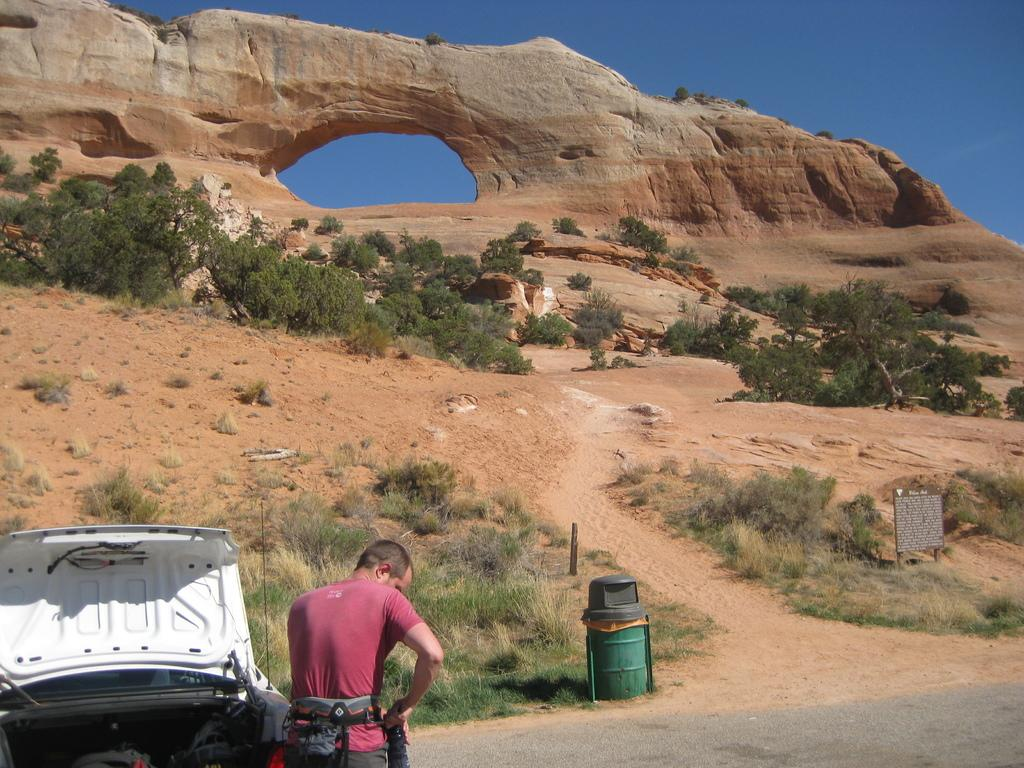What is the position of the man in the image? There is a man standing at the bottom of the image. What is located next to the man? There is a vehicle next to the man. What can be found in the center of the image? There is a bin in the center of the image. What architectural feature is visible in the background? There is an arch visible in the background. What type of vegetation is present in the background? Trees are present in the background. What is hanging on the wall in the background? There is a board in the background. What part of the natural environment is visible in the background? The sky is visible in the background. What type of notebook is the man using to write in the image? There is no notebook present in the image, and the man is not writing. What is the current temperature in the image? The image does not provide information about the temperature, and there is no weather instrument visible. 